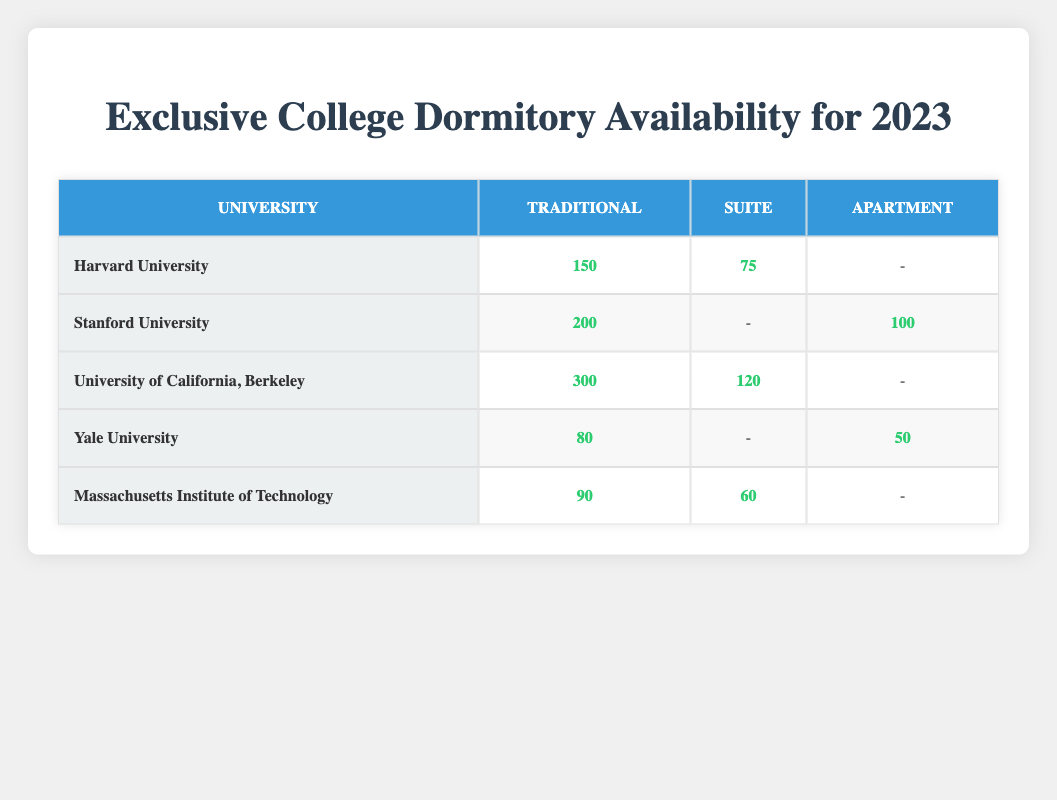What's the availability of Traditional dormitories at Stanford University? The table shows that Stanford University has 200 Traditional dormitories available for the year 2023.
Answer: 200 How many Suite dormitories are available at Harvard University? According to the table, there are 75 Suite dormitories available at Harvard University for 2023.
Answer: 75 Do any universities offer Apartment-type dormitories? Yes, the table indicates that Stanford University has 100 Apartment-type dormitories available and Yale University has 50.
Answer: Yes What is the total availability of dormitories at the University of California, Berkeley considering all types? The table shows that the totals are 300 for Traditional and 120 for Suite, adding them together (300 + 120) gives 420.
Answer: 420 Which university has the least availability of Traditional dormitories? For Traditional dormitories, Harvard has 150, Yale has 80, MIT has 90, Stanford has 200, and Berkeley has 300. The least is 80 at Yale University.
Answer: Yale University How many more Suite dormitories does MIT have compared to Yale? The table shows MIT has 60 Suite dormitories while Yale has none. Therefore, 60 - 0 = 60 more Suite dormitories at MIT than at Yale.
Answer: 60 Is it true that the University of California, Berkeley has the highest total availability of both Traditional and Suite dormitories? To determine this, we see Berkeley has 300 Traditional and 120 Suite that's 420 total. The other universities have lower totals (Harvard: 225, Stanford: 300, Yale: 130, MIT:150). So yes, Berkeley has the highest total.
Answer: Yes What is the average availability of Suite dormitories across all universities? The available Suite dormitories are 75 (Harvard) + 0 (Stanford) + 120 (Berkeley) + 0 (Yale) + 60 (MIT) = 255. There are four universities with Suite availability (Harvard, Berkeley, MIT), so the average is 255 / 4 = 63.75.
Answer: 63.75 What percentage of Yale University's dormitory availability is made up of Apartment-type dormitories? Yale has a total of 130 (80 Traditional + 50 Apartment). The Apartment-type availability is 50. To find the percentage: (50 / 130) * 100 = 38.46%.
Answer: 38.46% 